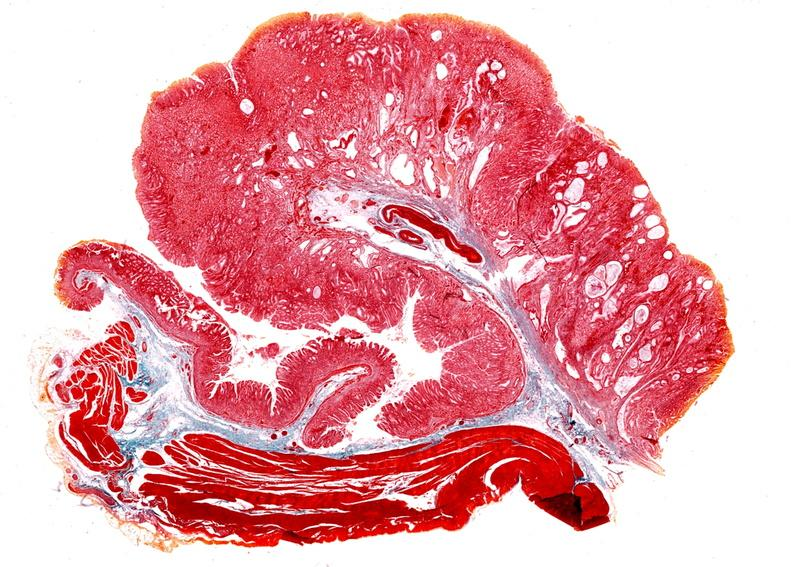does this image show stomach, giant rugose hyperplasia?
Answer the question using a single word or phrase. Yes 